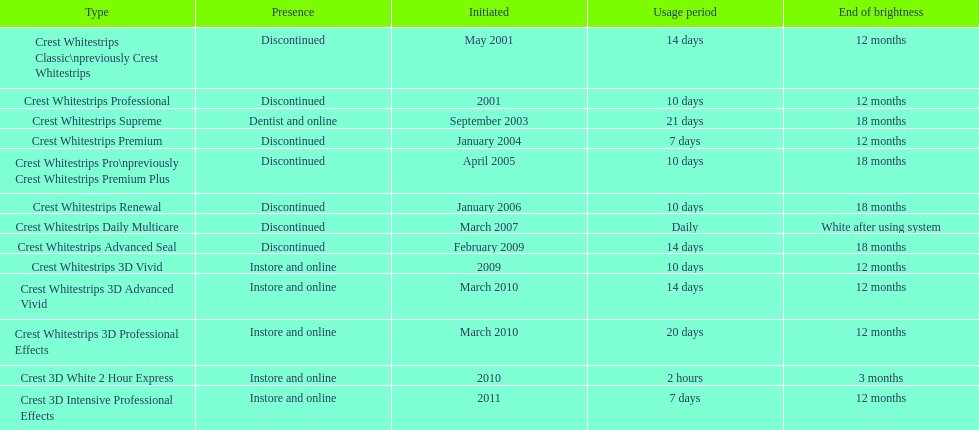What year did crest come out with crest white strips 3d vivid? 2009. Which crest product was also introduced he same year, but is now discontinued? Crest Whitestrips Advanced Seal. 